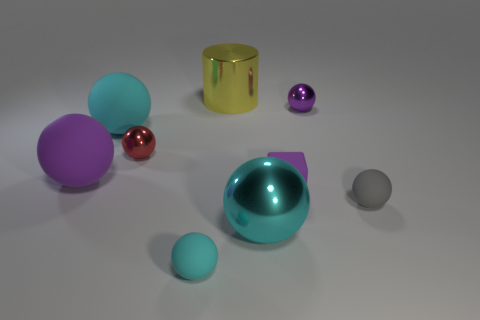Subtract all cyan cylinders. How many cyan balls are left? 3 Subtract 4 spheres. How many spheres are left? 3 Subtract all cyan spheres. How many spheres are left? 4 Subtract all big cyan spheres. How many spheres are left? 5 Subtract all green spheres. Subtract all brown cubes. How many spheres are left? 7 Add 1 gray spheres. How many objects exist? 10 Subtract all cubes. How many objects are left? 8 Subtract 2 cyan spheres. How many objects are left? 7 Subtract all red shiny spheres. Subtract all gray matte things. How many objects are left? 7 Add 5 gray balls. How many gray balls are left? 6 